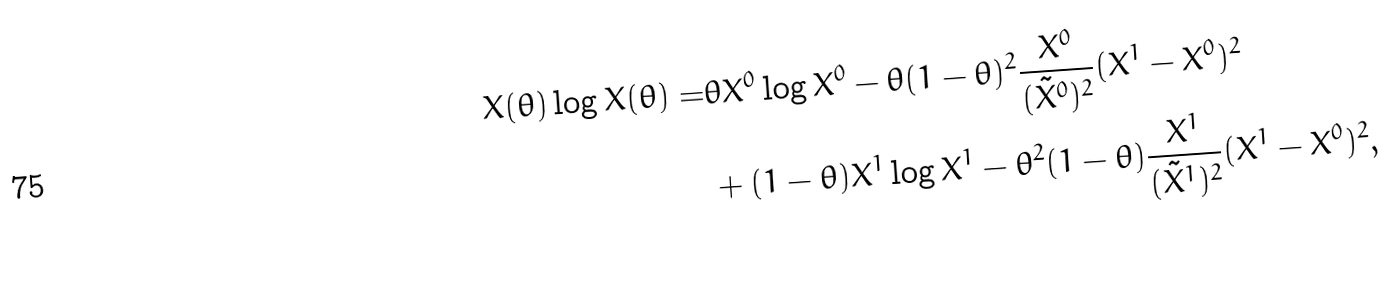<formula> <loc_0><loc_0><loc_500><loc_500>X ( \theta ) \log X ( \theta ) = & \theta X ^ { 0 } \log X ^ { 0 } - \theta ( 1 - \theta ) ^ { 2 } \frac { X ^ { 0 } } { ( \tilde { X } ^ { 0 } ) ^ { 2 } } ( X ^ { 1 } - X ^ { 0 } ) ^ { 2 } \\ & + ( 1 - \theta ) X ^ { 1 } \log X ^ { 1 } - \theta ^ { 2 } ( 1 - \theta ) \frac { X ^ { 1 } } { ( \tilde { X } ^ { 1 } ) ^ { 2 } } ( X ^ { 1 } - X ^ { 0 } ) ^ { 2 } ,</formula> 